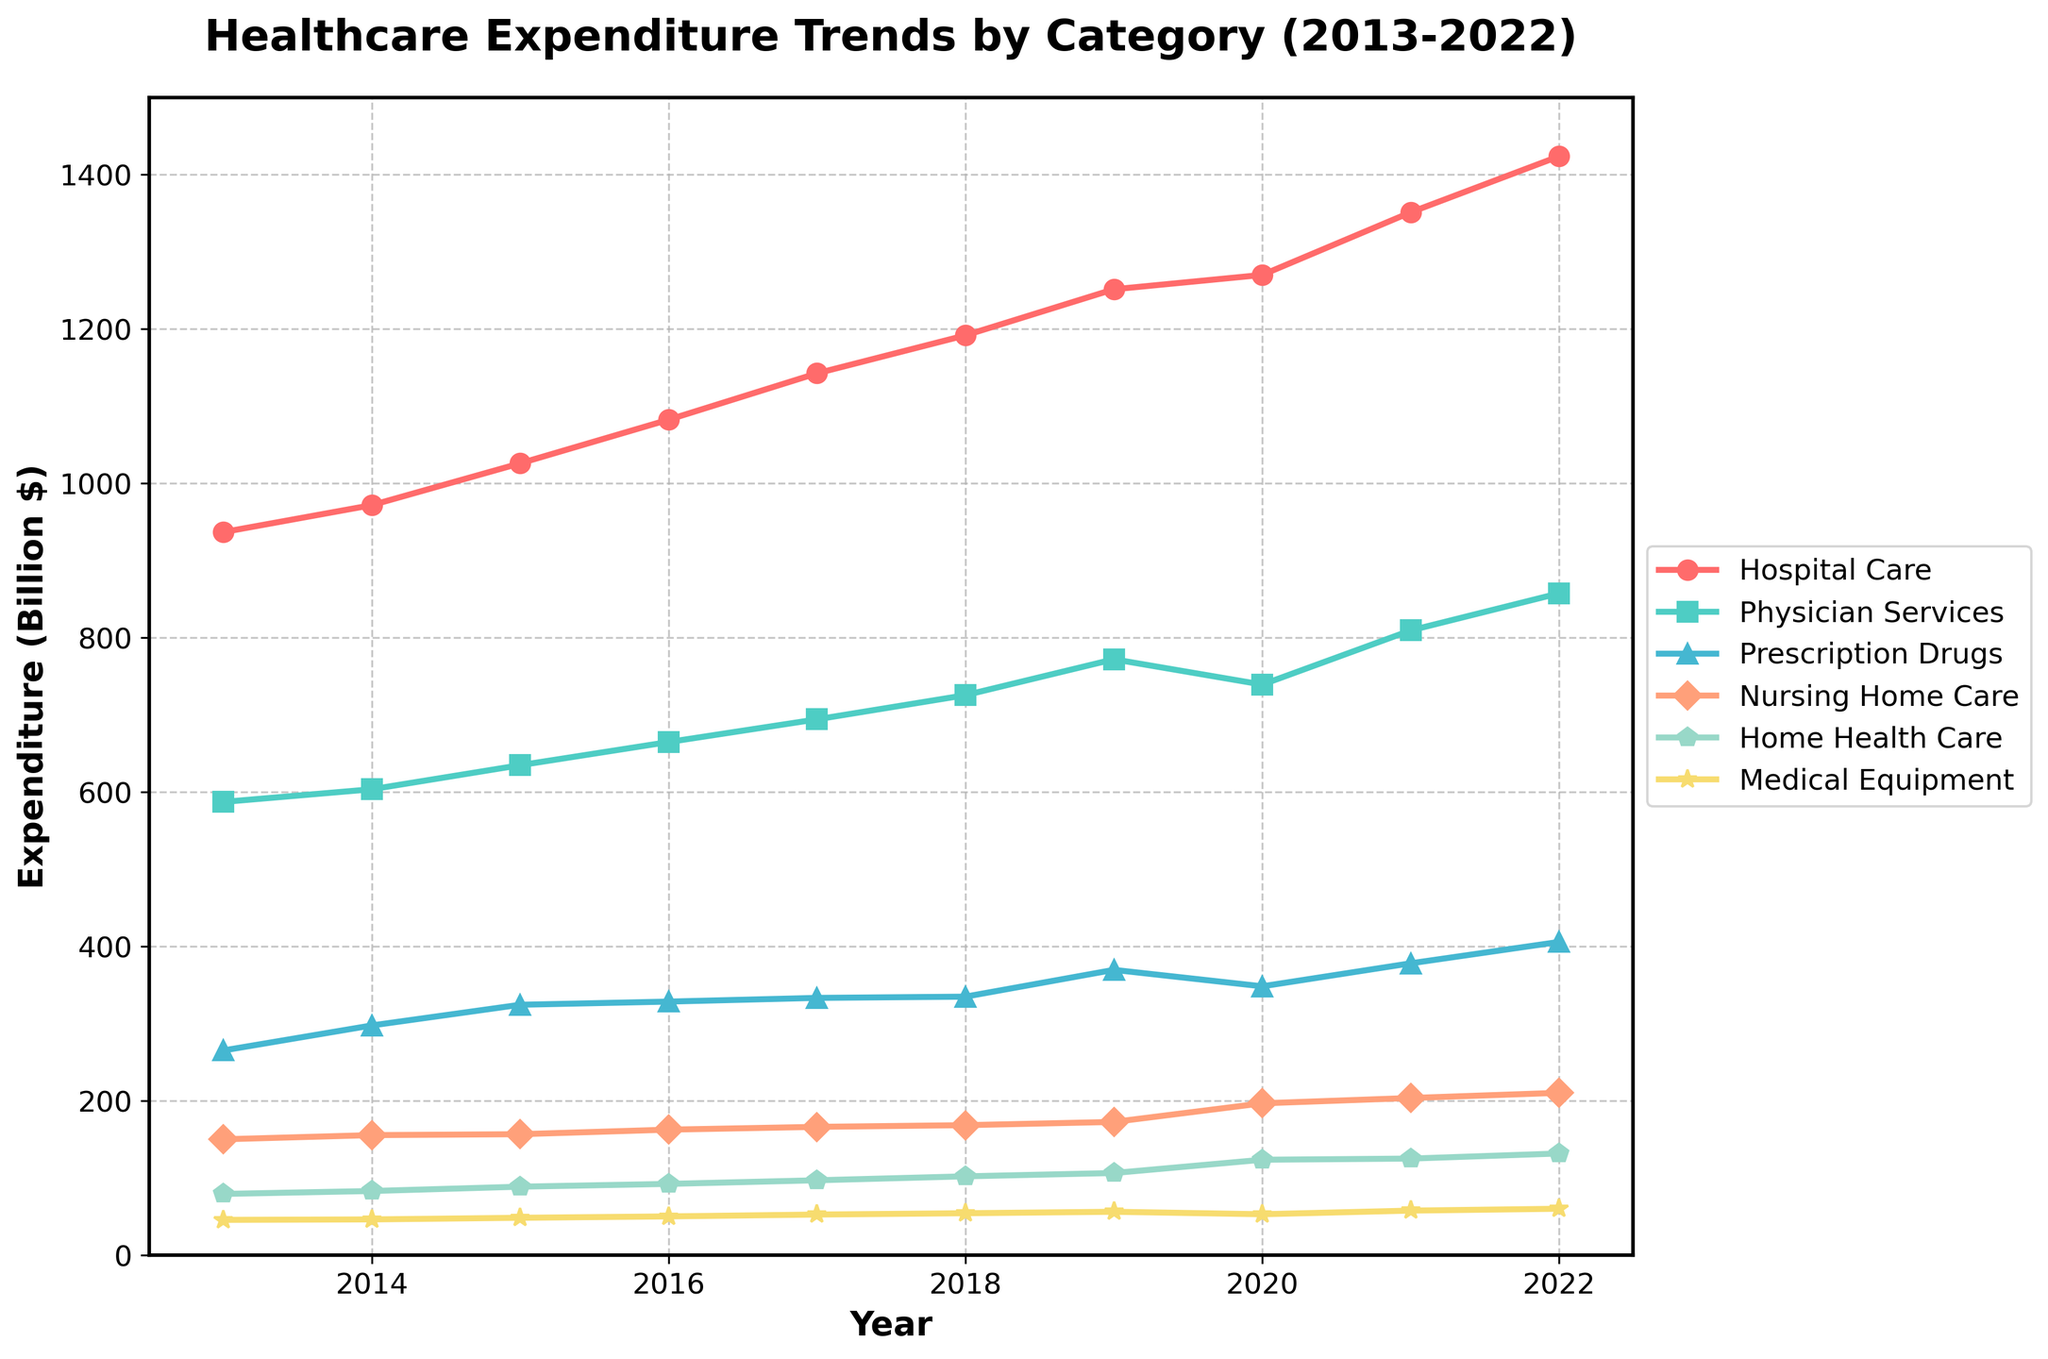What year had the highest healthcare expenditure on "Hospital Care"? The highest point on the "Hospital Care" line represents the year with the highest expenditure. By looking at the line color corresponding to "Hospital Care" and its maximum point, we can determine the year.
Answer: 2022 What is the total expenditure for "Prescription Drugs" and "Nursing Home Care" in 2020? We need to find the expenditure in 2020 for both "Prescription Drugs" and "Nursing Home Care" and sum them up. In 2020, "Prescription Drugs" is at 348.4 billion dollars and "Nursing Home Care" is at 196.8 billion dollars. Adding these gives 348.4 + 196.8 = 545.2 billion dollars.
Answer: 545.2 billion dollars How does the expenditure on "Home Health Care" compare between 2018 and 2022? To compare, look at the expenditure values for "Home Health Care" in 2018 and 2022. In 2018, it's 102.2 billion dollars, and in 2022, it's 131.8 billion dollars. The expenditure increased from 2018 to 2022.
Answer: Increased Which category experienced the most significant increase in expenditure from 2013 to 2022? By visually comparing the slopes of the lines from 2013 to 2022, the category with the steepest increase represents the most significant expenditure rise. "Hospital Care" shows a considerable increase from approximately 936.9 billion dollars in 2013 to 1423.8 billion dollars in 2022.
Answer: Hospital Care Calculate the average yearly expenditure on "Medical Equipment" from 2013 to 2022. Sum the expenditure values for "Medical Equipment" from 2013 to 2022 and divide by the number of years (10). (45.8 + 46.4 + 48.5 + 50.3 + 52.7 + 54.4 + 56.3 + 53.1 + 57.8 + 60.2) / 10 = 52.55 billion dollars.
Answer: 52.55 billion dollars In which year was the expenditure on "Physician Services" highest? Identify the highest point on the "Physician Services" line. The year with the highest expenditure for "Physician Services" is marked at the highest point on this line, which is in 2022 with an expenditure of 857.6 billion dollars.
Answer: 2022 By how much did the expenditure on "Home Health Care" increase between 2013 and 2020? Subtract the expenditure in 2013 from that in 2020 for "Home Health Care". The values are 79.4 billion dollars in 2013 and 123.7 billion dollars in 2020. The increase is 123.7 - 79.4 = 44.3 billion dollars.
Answer: 44.3 billion dollars What is the overall trend for "Nursing Home Care" expenditure from 2013 to 2022? Review the line for "Nursing Home Care". The line shows a general upward trend, indicating that the expenditure has consistently increased over the years from 150.2 billion dollars in 2013 to 210.4 billion dollars in 2022.
Answer: Upward trend Compare the expenditures on "Hospital Care" and "Prescription Drugs" in 2019. Which was higher and by how much? Subtract the expenditure on "Prescription Drugs" from the expenditure on "Hospital Care" in 2019. Hospital Care is 1251.5 billion dollars, and Prescription Drugs are 369.7 billion dollars, so the difference is 1251.5 - 369.7 = 881.8 billion dollars.
Answer: Hospital Care by 881.8 billion dollars 